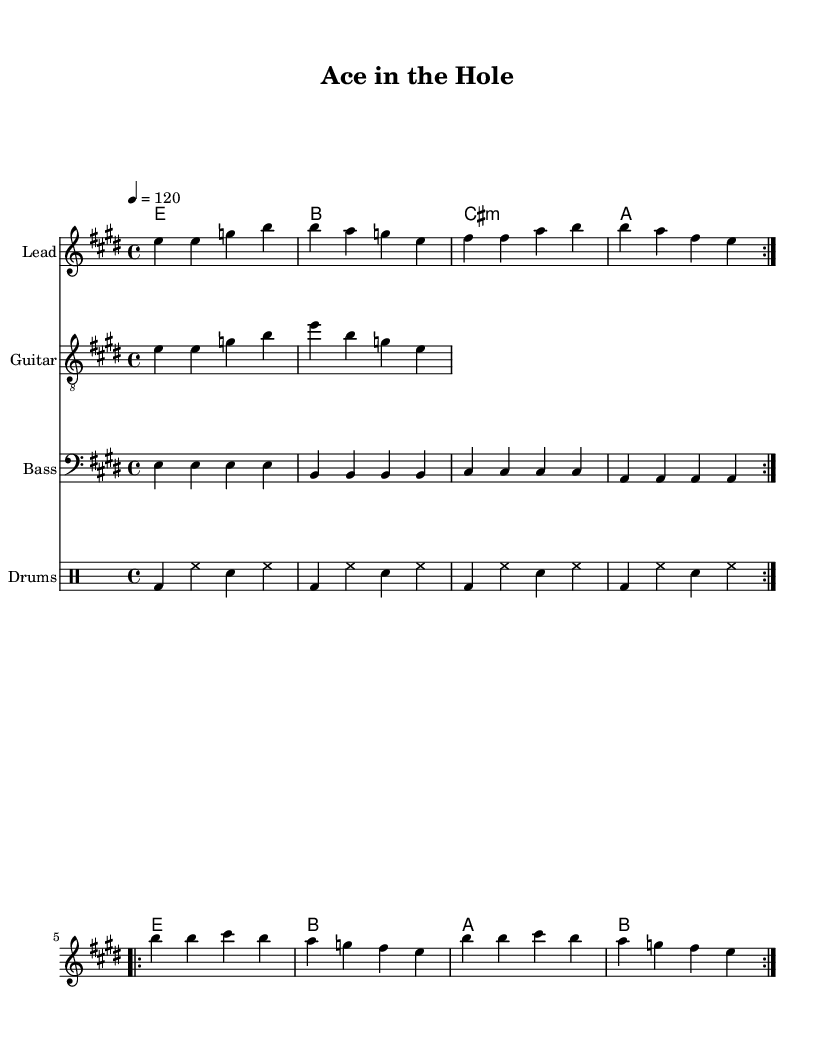What is the key signature of this music? The key signature is indicated at the beginning of the score, which shows two sharps. This corresponds to the key of E major.
Answer: E major What is the time signature of this music? The time signature is displayed at the beginning of the score next to the key signature. It shows 4/4, meaning there are four beats per measure and a quarter note receives one beat.
Answer: 4/4 What is the tempo marking of the piece? The tempo is given at the beginning of the music with a numerical indication, stating "4 = 120". This means there are 120 beats per minute.
Answer: 120 How many volta sections are there in the melody? By analyzing the score, the melody section has two repeat patterns marked by “\repeat volta 2,” indicating that it should be played two times.
Answer: 2 What is the instrument name for the second staff? The second staff is labeled "Guitar," which indicates the type of instrument playing the notated music on that staff.
Answer: Guitar What are the last lyrics of the chorus? The last part of the chorus can be found towards the end, where the text states, "I've got an ace in the hole." This is the conclusion of the chorus's lyrical line.
Answer: I've got an ace in the hole What section of the song is described by the lyrics "Serving up a storm, on this court of dreams"? The lyrics "Serving up a storm, on this court of dreams" are part of the first verse in the song, indicating the introductory section before the chorus begins.
Answer: Verse One 